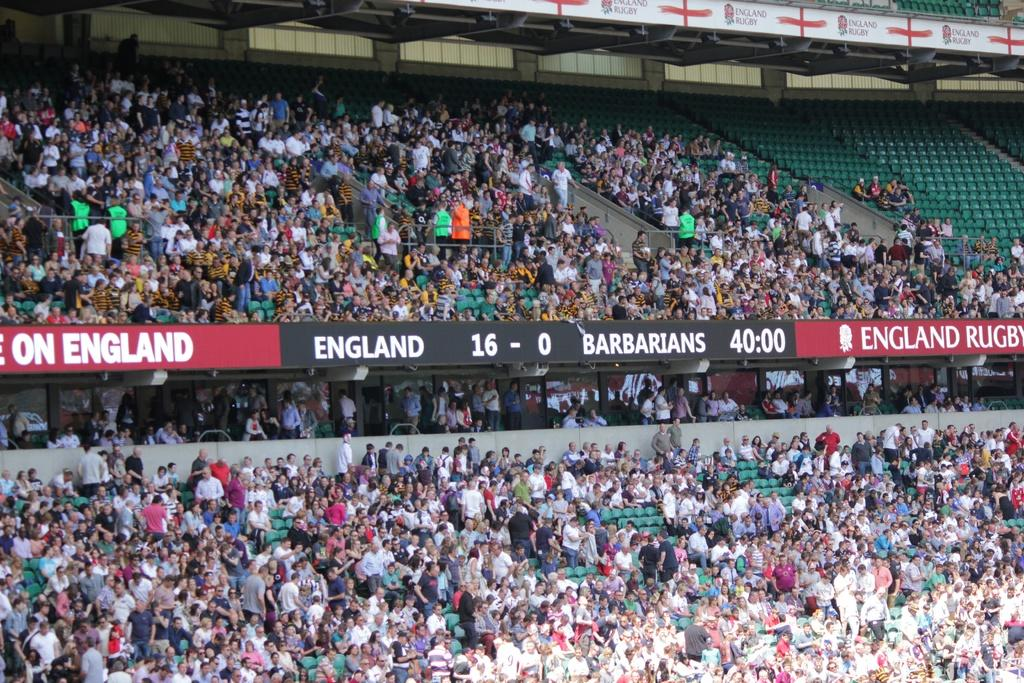What is the main structure visible in the image? There is a stadium in the image. Are there any electronic displays in the image? Yes, there are two digital boards in the image. Can you describe the crowd in the image? There are many people in the image. Where are some empty seats located in the image? There are vacant chairs at the right top of the image. What type of fruit is being sold at the stadium in the image? There is no indication of fruit being sold or present in the image. 